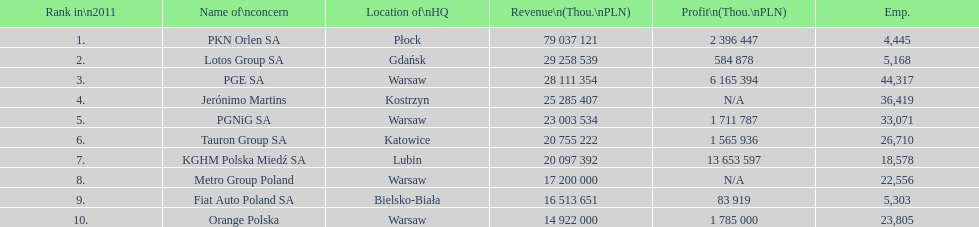What is the difference in employees for rank 1 and rank 3? 39,872 employees. 